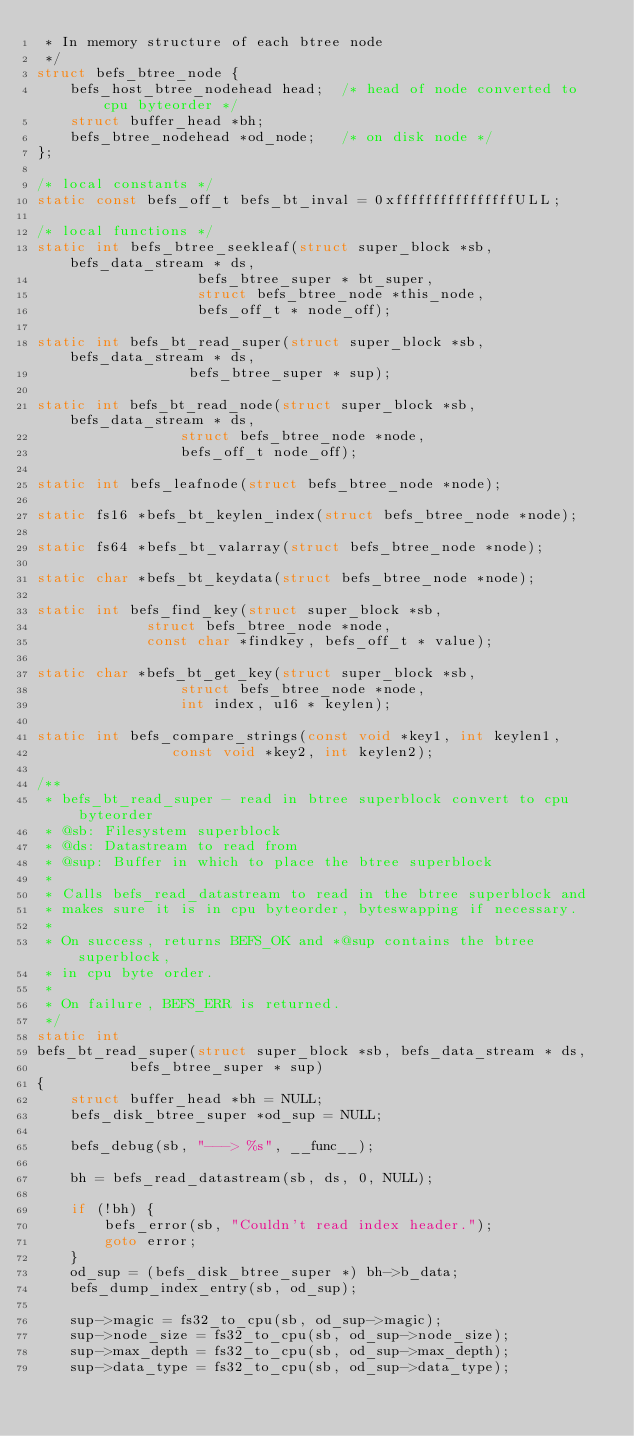<code> <loc_0><loc_0><loc_500><loc_500><_C_> * In memory structure of each btree node
 */
struct befs_btree_node {
	befs_host_btree_nodehead head;	/* head of node converted to cpu byteorder */
	struct buffer_head *bh;
	befs_btree_nodehead *od_node;	/* on disk node */
};

/* local constants */
static const befs_off_t befs_bt_inval = 0xffffffffffffffffULL;

/* local functions */
static int befs_btree_seekleaf(struct super_block *sb, befs_data_stream * ds,
			       befs_btree_super * bt_super,
			       struct befs_btree_node *this_node,
			       befs_off_t * node_off);

static int befs_bt_read_super(struct super_block *sb, befs_data_stream * ds,
			      befs_btree_super * sup);

static int befs_bt_read_node(struct super_block *sb, befs_data_stream * ds,
			     struct befs_btree_node *node,
			     befs_off_t node_off);

static int befs_leafnode(struct befs_btree_node *node);

static fs16 *befs_bt_keylen_index(struct befs_btree_node *node);

static fs64 *befs_bt_valarray(struct befs_btree_node *node);

static char *befs_bt_keydata(struct befs_btree_node *node);

static int befs_find_key(struct super_block *sb,
			 struct befs_btree_node *node,
			 const char *findkey, befs_off_t * value);

static char *befs_bt_get_key(struct super_block *sb,
			     struct befs_btree_node *node,
			     int index, u16 * keylen);

static int befs_compare_strings(const void *key1, int keylen1,
				const void *key2, int keylen2);

/**
 * befs_bt_read_super - read in btree superblock convert to cpu byteorder
 * @sb: Filesystem superblock
 * @ds: Datastream to read from
 * @sup: Buffer in which to place the btree superblock
 *
 * Calls befs_read_datastream to read in the btree superblock and
 * makes sure it is in cpu byteorder, byteswapping if necessary.
 *
 * On success, returns BEFS_OK and *@sup contains the btree superblock,
 * in cpu byte order.
 *
 * On failure, BEFS_ERR is returned.
 */
static int
befs_bt_read_super(struct super_block *sb, befs_data_stream * ds,
		   befs_btree_super * sup)
{
	struct buffer_head *bh = NULL;
	befs_disk_btree_super *od_sup = NULL;

	befs_debug(sb, "---> %s", __func__);

	bh = befs_read_datastream(sb, ds, 0, NULL);

	if (!bh) {
		befs_error(sb, "Couldn't read index header.");
		goto error;
	}
	od_sup = (befs_disk_btree_super *) bh->b_data;
	befs_dump_index_entry(sb, od_sup);

	sup->magic = fs32_to_cpu(sb, od_sup->magic);
	sup->node_size = fs32_to_cpu(sb, od_sup->node_size);
	sup->max_depth = fs32_to_cpu(sb, od_sup->max_depth);
	sup->data_type = fs32_to_cpu(sb, od_sup->data_type);</code> 